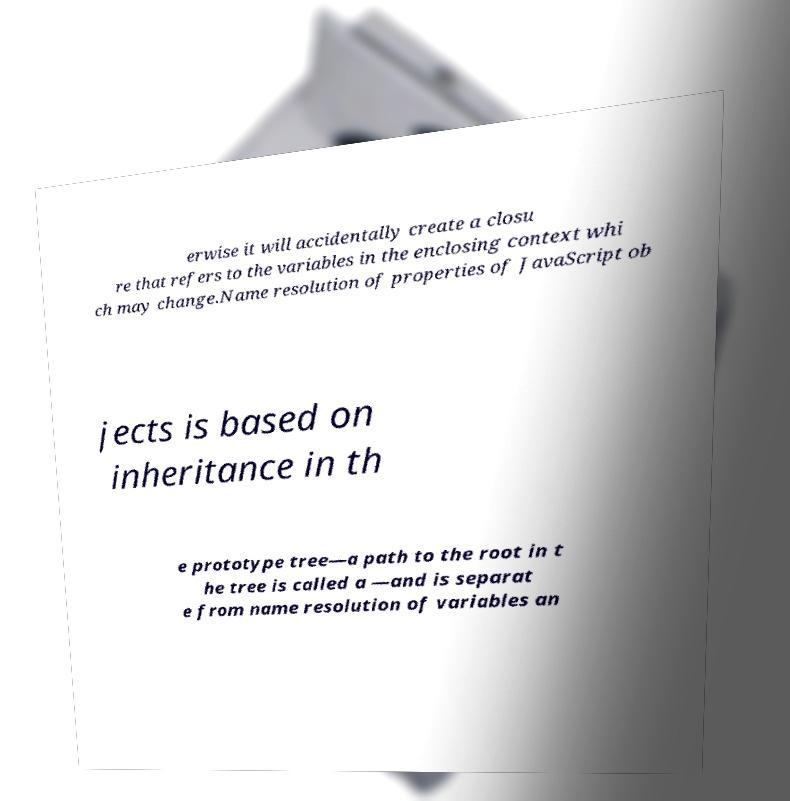Looking at the text in the image, could you explain the context or scenario where such terminology might be used? The screenshot you're looking at is likely from a learning material or a technical document focused on advanced JavaScript topics. The terminology used - including closures, prototype chains, and property resolution - is typically discussed in contexts involving complex JavaScript programming, such as developing libraries or frameworks, or in-depth debugging of applications where understanding scope and inheritance is crucial. 